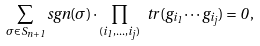Convert formula to latex. <formula><loc_0><loc_0><loc_500><loc_500>\sum _ { \sigma \in S _ { n + 1 } } s g n ( \sigma ) \cdot \prod _ { ( i _ { 1 } , \dots , i _ { j } ) } \ t r ( g _ { i _ { 1 } } \cdots g _ { i _ { j } } ) = 0 \, ,</formula> 